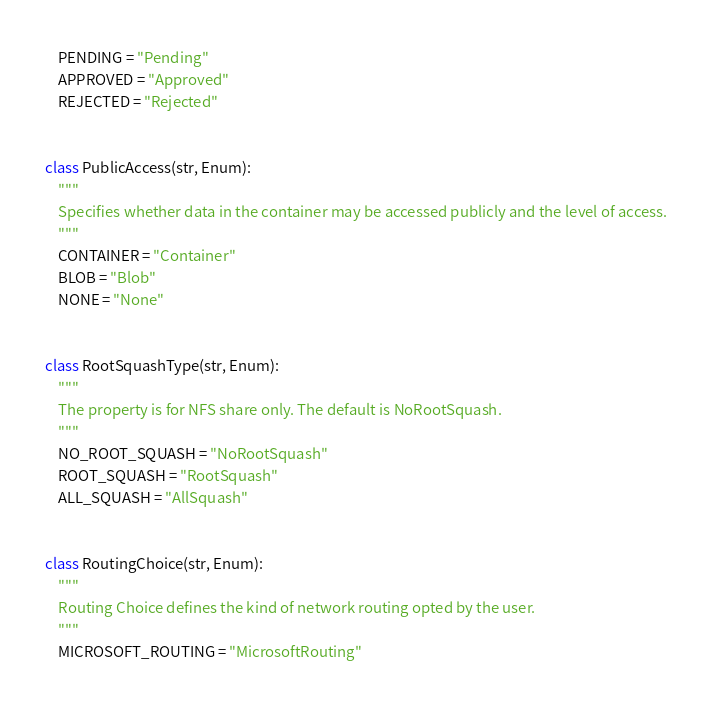Convert code to text. <code><loc_0><loc_0><loc_500><loc_500><_Python_>    PENDING = "Pending"
    APPROVED = "Approved"
    REJECTED = "Rejected"


class PublicAccess(str, Enum):
    """
    Specifies whether data in the container may be accessed publicly and the level of access.
    """
    CONTAINER = "Container"
    BLOB = "Blob"
    NONE = "None"


class RootSquashType(str, Enum):
    """
    The property is for NFS share only. The default is NoRootSquash.
    """
    NO_ROOT_SQUASH = "NoRootSquash"
    ROOT_SQUASH = "RootSquash"
    ALL_SQUASH = "AllSquash"


class RoutingChoice(str, Enum):
    """
    Routing Choice defines the kind of network routing opted by the user.
    """
    MICROSOFT_ROUTING = "MicrosoftRouting"</code> 